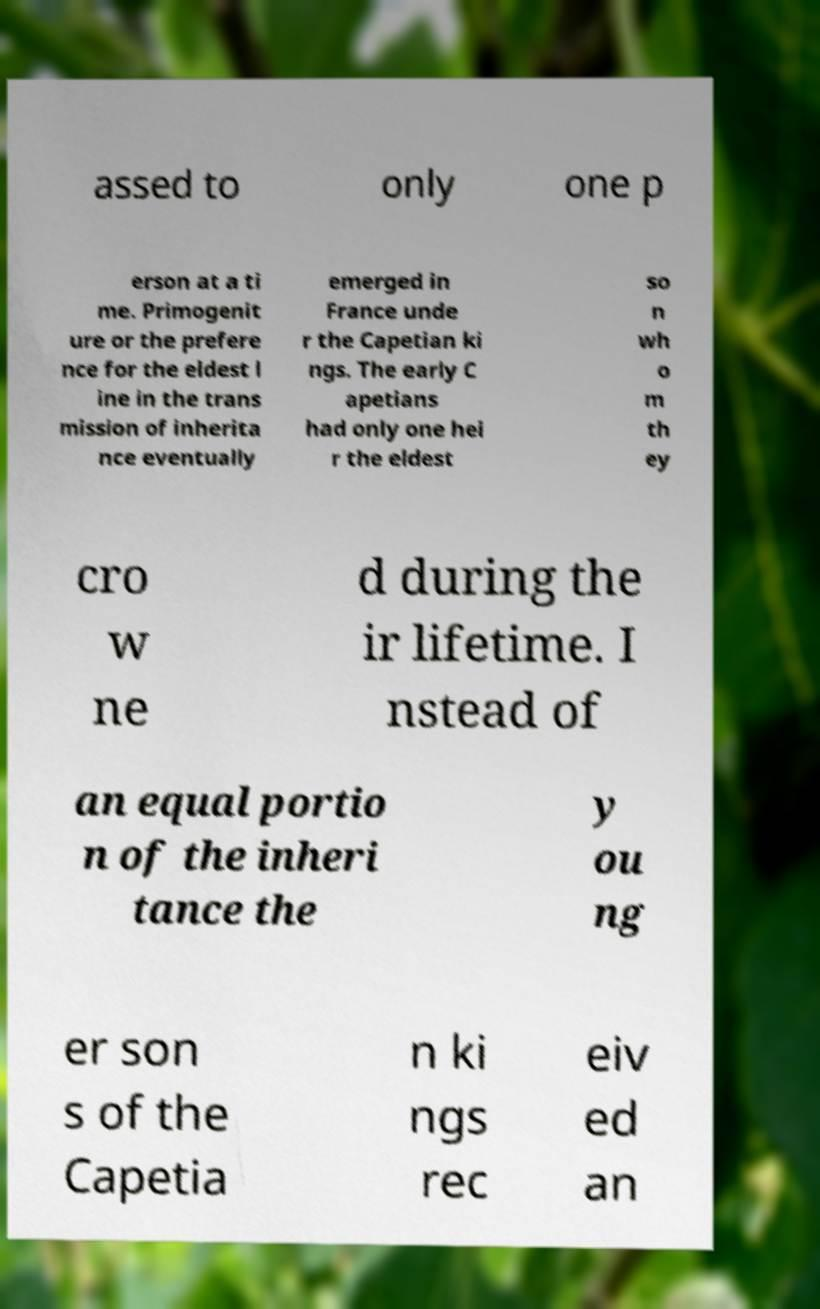Can you read and provide the text displayed in the image?This photo seems to have some interesting text. Can you extract and type it out for me? assed to only one p erson at a ti me. Primogenit ure or the prefere nce for the eldest l ine in the trans mission of inherita nce eventually emerged in France unde r the Capetian ki ngs. The early C apetians had only one hei r the eldest so n wh o m th ey cro w ne d during the ir lifetime. I nstead of an equal portio n of the inheri tance the y ou ng er son s of the Capetia n ki ngs rec eiv ed an 